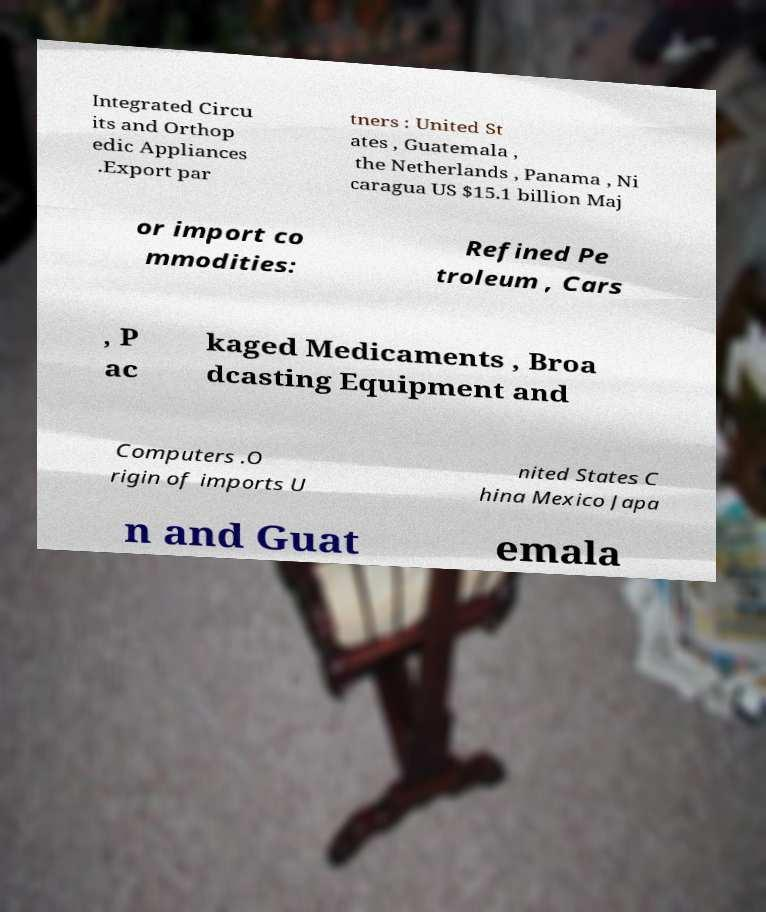I need the written content from this picture converted into text. Can you do that? Integrated Circu its and Orthop edic Appliances .Export par tners : United St ates , Guatemala , the Netherlands , Panama , Ni caragua US $15.1 billion Maj or import co mmodities: Refined Pe troleum , Cars , P ac kaged Medicaments , Broa dcasting Equipment and Computers .O rigin of imports U nited States C hina Mexico Japa n and Guat emala 